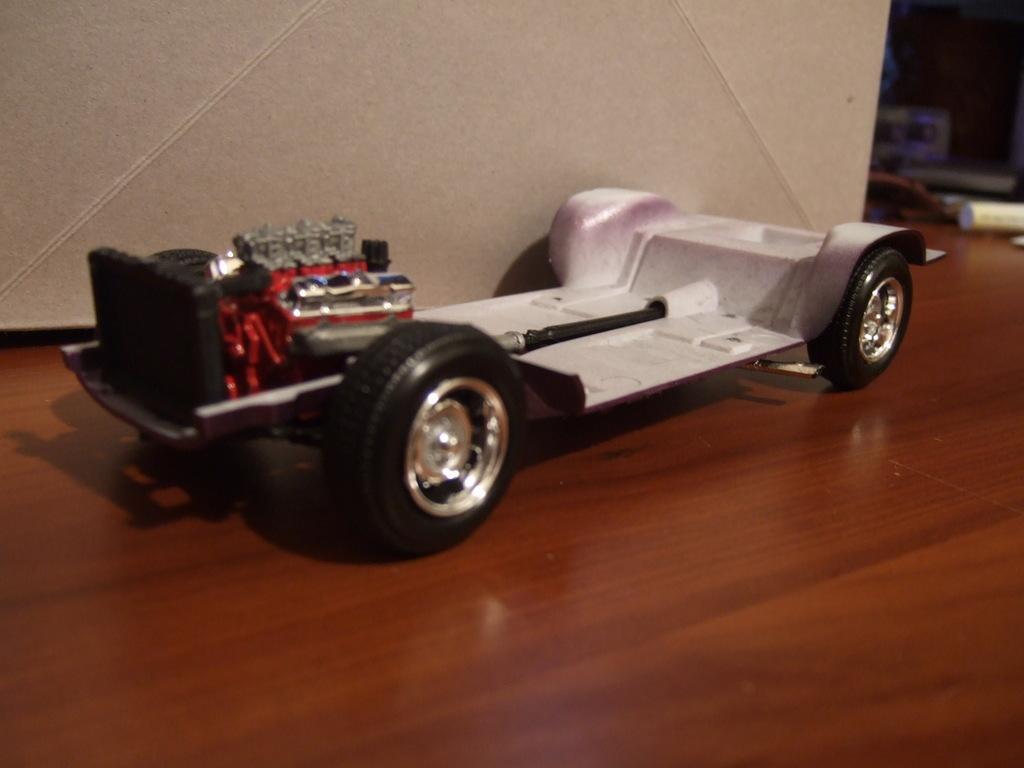In one or two sentences, can you explain what this image depicts? In this image, we can see a toy car on the wooden surface. 